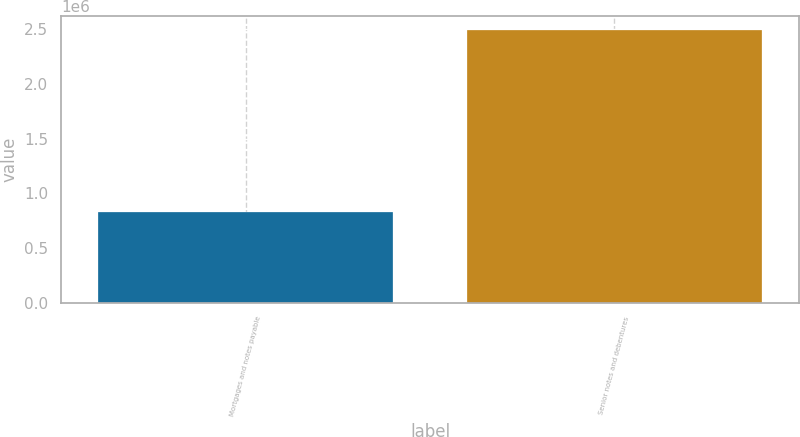Convert chart to OTSL. <chart><loc_0><loc_0><loc_500><loc_500><bar_chart><fcel>Mortgages and notes payable<fcel>Senior notes and debentures<nl><fcel>824419<fcel>2.49844e+06<nl></chart> 